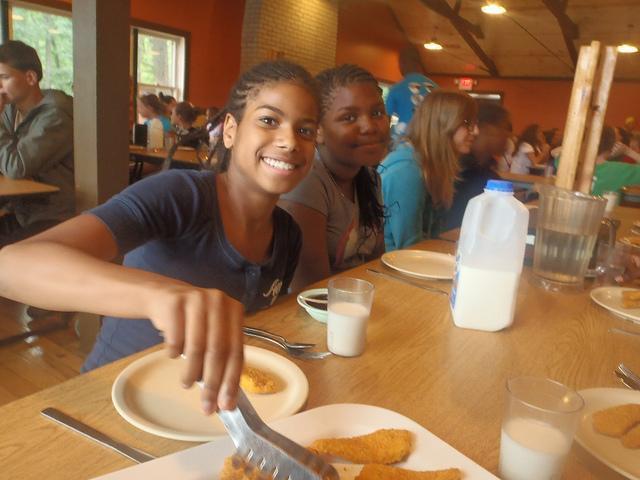How many windows are in the scene?
Give a very brief answer. 2. How many people are there?
Give a very brief answer. 5. How many cups can you see?
Give a very brief answer. 3. How many boats are there?
Give a very brief answer. 0. 